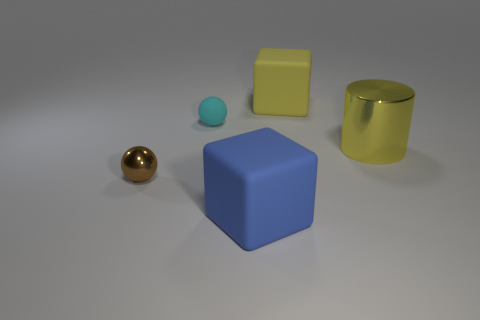What number of cylinders are either large shiny objects or cyan things?
Ensure brevity in your answer.  1. Do the big cube that is behind the rubber sphere and the small cyan thing that is behind the blue rubber cube have the same material?
Provide a succinct answer. Yes. There is a blue thing that is the same size as the yellow matte cube; what is its shape?
Make the answer very short. Cube. How many other things are the same color as the tiny matte ball?
Offer a very short reply. 0. What number of yellow objects are shiny cylinders or tiny balls?
Your response must be concise. 1. Does the metal thing to the left of the blue rubber cube have the same shape as the rubber thing in front of the tiny cyan ball?
Give a very brief answer. No. What number of other objects are the same material as the large yellow cylinder?
Your response must be concise. 1. Are there any large metallic objects that are left of the big yellow object that is behind the big yellow thing that is in front of the cyan rubber sphere?
Provide a succinct answer. No. Do the cylinder and the small cyan sphere have the same material?
Make the answer very short. No. Is there any other thing that is the same shape as the large yellow metal object?
Provide a succinct answer. No. 